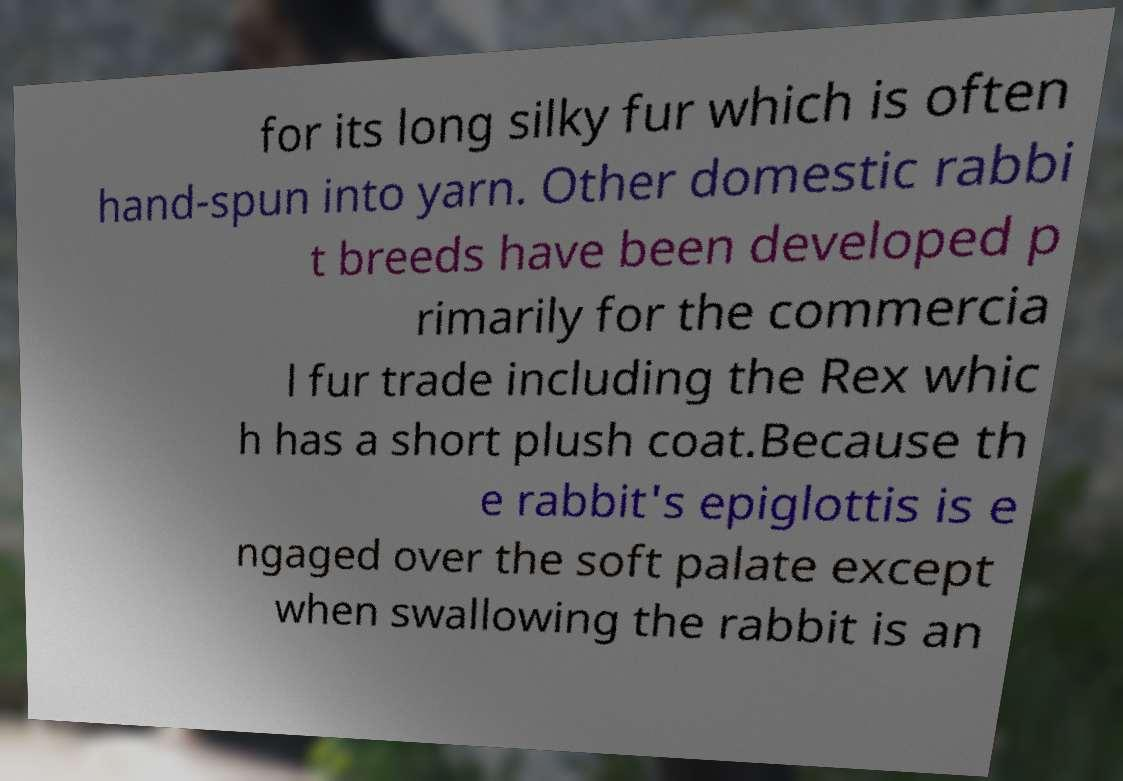I need the written content from this picture converted into text. Can you do that? for its long silky fur which is often hand-spun into yarn. Other domestic rabbi t breeds have been developed p rimarily for the commercia l fur trade including the Rex whic h has a short plush coat.Because th e rabbit's epiglottis is e ngaged over the soft palate except when swallowing the rabbit is an 